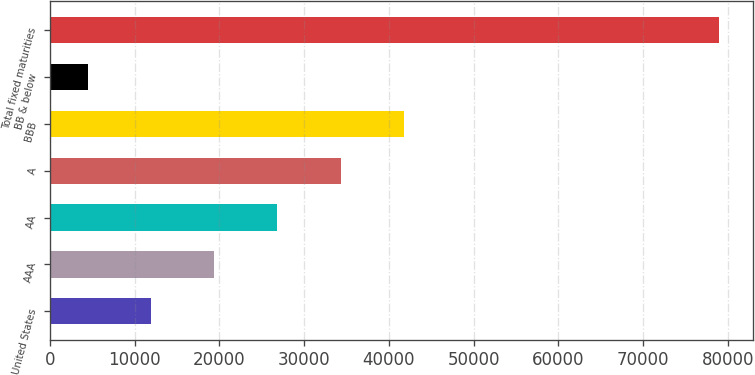Convert chart to OTSL. <chart><loc_0><loc_0><loc_500><loc_500><bar_chart><fcel>United States<fcel>AAA<fcel>AA<fcel>A<fcel>BBB<fcel>BB & below<fcel>Total fixed maturities<nl><fcel>11949.6<fcel>19397.2<fcel>26844.8<fcel>34292.4<fcel>41740<fcel>4502<fcel>78978<nl></chart> 